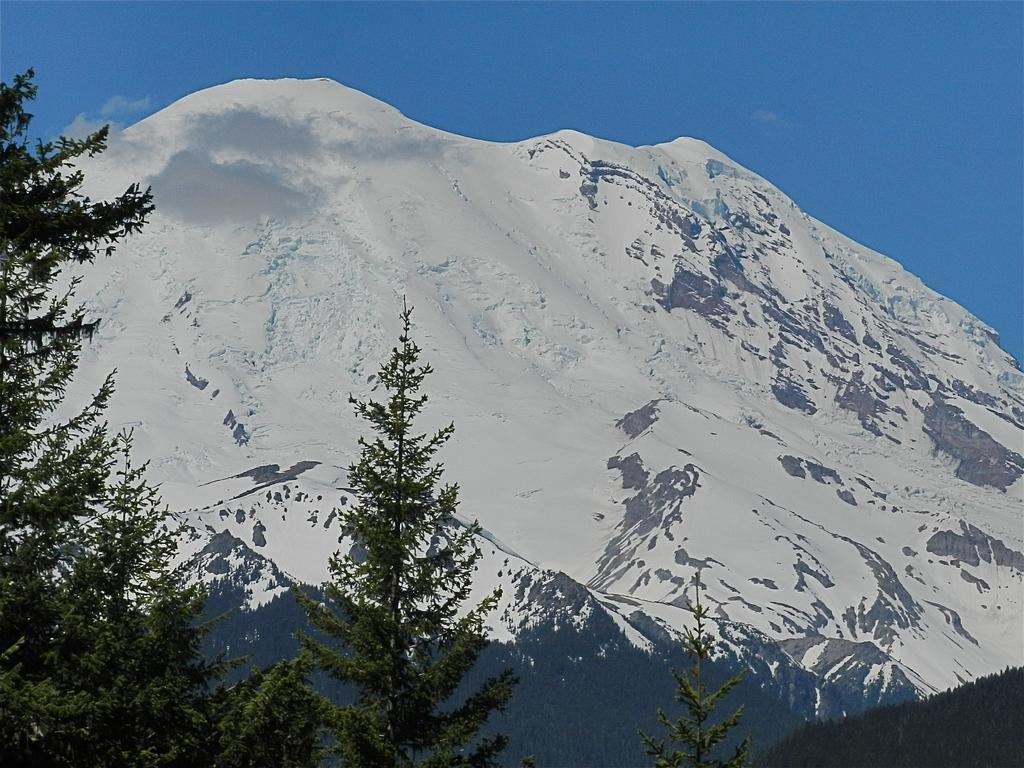How would you summarize this image in a sentence or two? In this image we can see group of trees ,mountain and sky. 